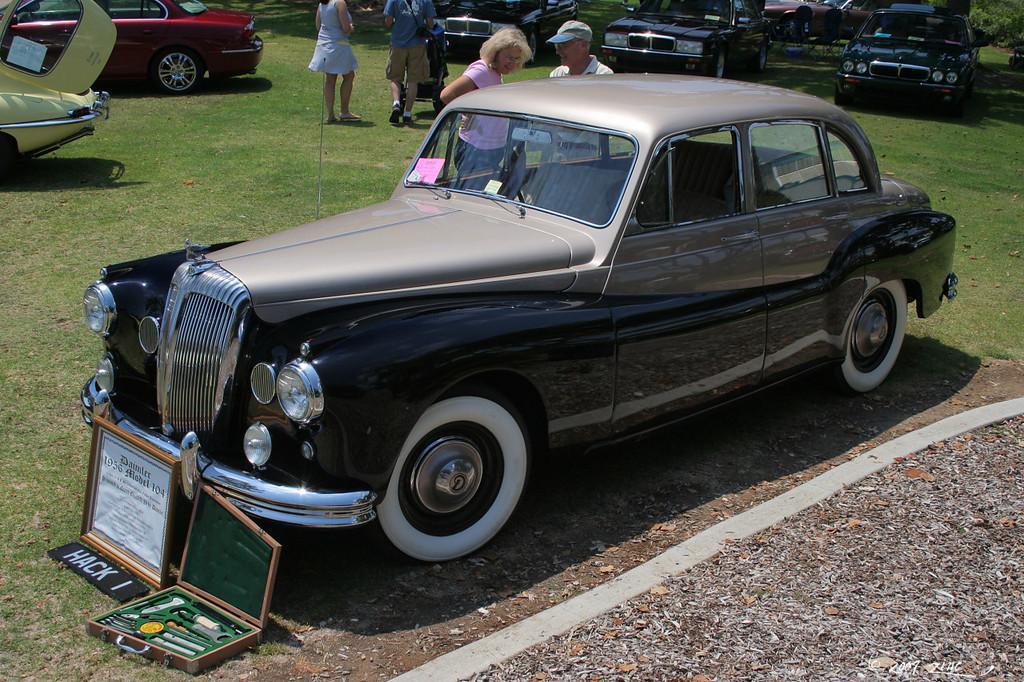Could you give a brief overview of what you see in this image? In this image I can see an open grass ground and on it I can see few cars and I can see few people are standing. Here I can see a board and on it I can see something is written. In the background I can see tree and few other things over here. 